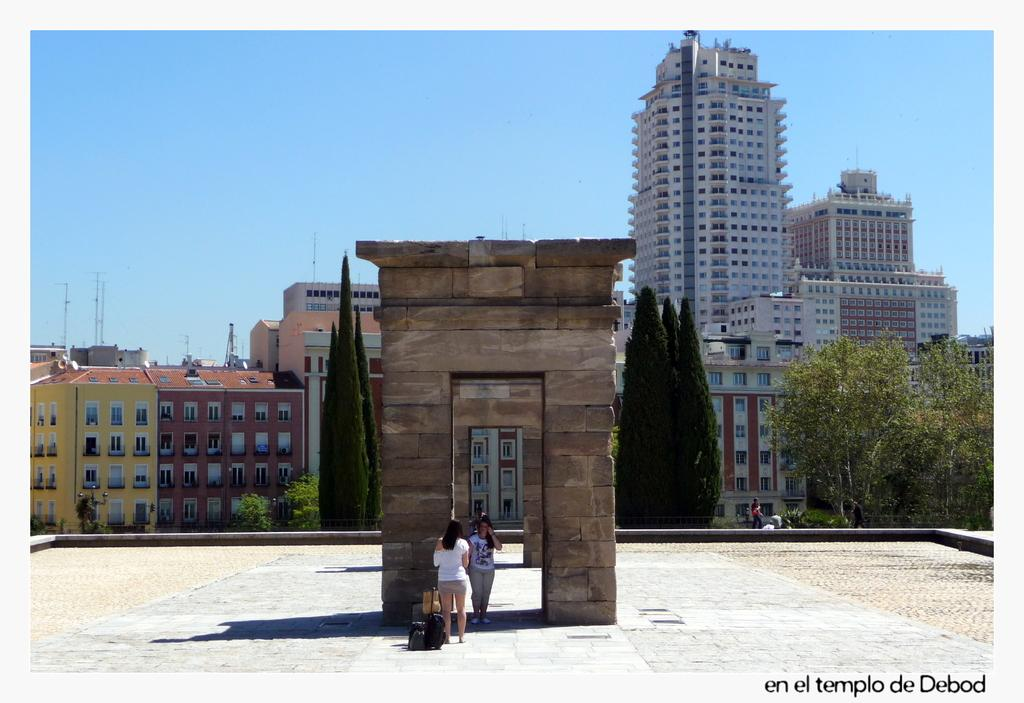How many women are present in the image? There are two women standing in the image. What is the surface on which the women are standing? The women are standing on the ground. What can be seen in the background of the image? There is a group of trees, buildings, a person, and the sky visible in the background of the image. What type of crook is being used by the women in the image? There is no crook present in the image; the women are simply standing on the ground. What kind of apparatus is being used by the person visible in the background of the image? There is no apparatus visible in the image; only the person is present in the background. 